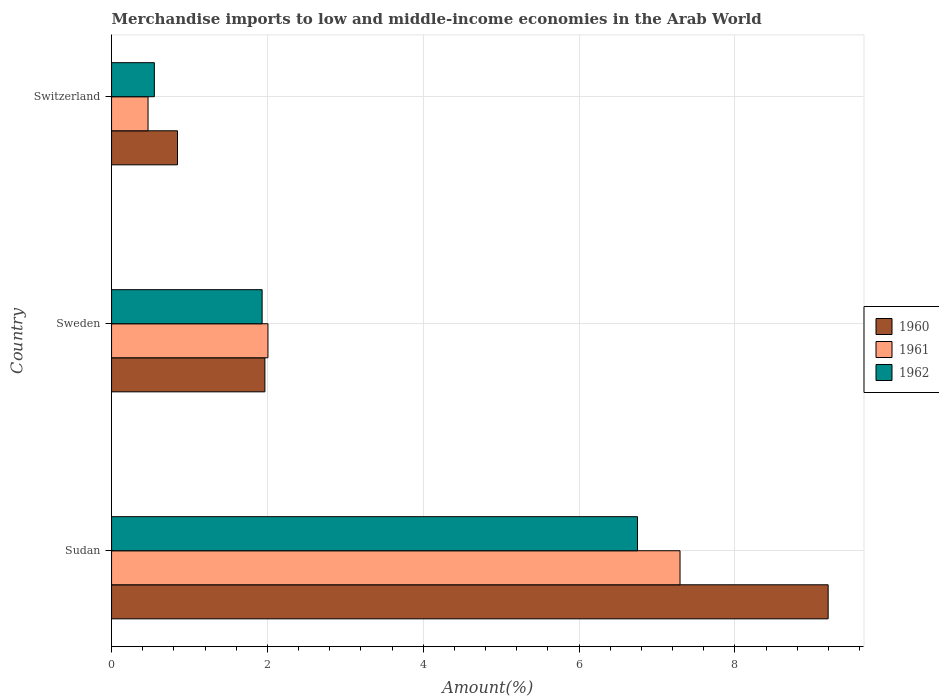How many groups of bars are there?
Keep it short and to the point. 3. Are the number of bars per tick equal to the number of legend labels?
Keep it short and to the point. Yes. Are the number of bars on each tick of the Y-axis equal?
Offer a terse response. Yes. How many bars are there on the 1st tick from the top?
Keep it short and to the point. 3. What is the label of the 2nd group of bars from the top?
Make the answer very short. Sweden. In how many cases, is the number of bars for a given country not equal to the number of legend labels?
Your response must be concise. 0. What is the percentage of amount earned from merchandise imports in 1960 in Sweden?
Provide a succinct answer. 1.97. Across all countries, what is the maximum percentage of amount earned from merchandise imports in 1961?
Give a very brief answer. 7.3. Across all countries, what is the minimum percentage of amount earned from merchandise imports in 1962?
Your answer should be very brief. 0.55. In which country was the percentage of amount earned from merchandise imports in 1962 maximum?
Make the answer very short. Sudan. In which country was the percentage of amount earned from merchandise imports in 1960 minimum?
Provide a succinct answer. Switzerland. What is the total percentage of amount earned from merchandise imports in 1962 in the graph?
Give a very brief answer. 9.23. What is the difference between the percentage of amount earned from merchandise imports in 1960 in Sudan and that in Sweden?
Offer a very short reply. 7.23. What is the difference between the percentage of amount earned from merchandise imports in 1960 in Switzerland and the percentage of amount earned from merchandise imports in 1961 in Sweden?
Give a very brief answer. -1.16. What is the average percentage of amount earned from merchandise imports in 1960 per country?
Keep it short and to the point. 4. What is the difference between the percentage of amount earned from merchandise imports in 1961 and percentage of amount earned from merchandise imports in 1960 in Sweden?
Keep it short and to the point. 0.04. What is the ratio of the percentage of amount earned from merchandise imports in 1962 in Sudan to that in Sweden?
Keep it short and to the point. 3.49. Is the percentage of amount earned from merchandise imports in 1961 in Sudan less than that in Sweden?
Give a very brief answer. No. Is the difference between the percentage of amount earned from merchandise imports in 1961 in Sweden and Switzerland greater than the difference between the percentage of amount earned from merchandise imports in 1960 in Sweden and Switzerland?
Keep it short and to the point. Yes. What is the difference between the highest and the second highest percentage of amount earned from merchandise imports in 1962?
Give a very brief answer. 4.82. What is the difference between the highest and the lowest percentage of amount earned from merchandise imports in 1962?
Provide a short and direct response. 6.2. Is the sum of the percentage of amount earned from merchandise imports in 1962 in Sweden and Switzerland greater than the maximum percentage of amount earned from merchandise imports in 1961 across all countries?
Your response must be concise. No. What does the 2nd bar from the bottom in Sweden represents?
Provide a succinct answer. 1961. How many bars are there?
Provide a short and direct response. 9. Are all the bars in the graph horizontal?
Your answer should be very brief. Yes. Does the graph contain any zero values?
Offer a very short reply. No. What is the title of the graph?
Your response must be concise. Merchandise imports to low and middle-income economies in the Arab World. Does "1966" appear as one of the legend labels in the graph?
Your response must be concise. No. What is the label or title of the X-axis?
Offer a terse response. Amount(%). What is the Amount(%) of 1960 in Sudan?
Your answer should be very brief. 9.2. What is the Amount(%) of 1961 in Sudan?
Your response must be concise. 7.3. What is the Amount(%) of 1962 in Sudan?
Provide a succinct answer. 6.75. What is the Amount(%) of 1960 in Sweden?
Make the answer very short. 1.97. What is the Amount(%) in 1961 in Sweden?
Your answer should be very brief. 2.01. What is the Amount(%) in 1962 in Sweden?
Your answer should be very brief. 1.93. What is the Amount(%) in 1960 in Switzerland?
Your answer should be compact. 0.85. What is the Amount(%) of 1961 in Switzerland?
Make the answer very short. 0.47. What is the Amount(%) of 1962 in Switzerland?
Give a very brief answer. 0.55. Across all countries, what is the maximum Amount(%) in 1960?
Keep it short and to the point. 9.2. Across all countries, what is the maximum Amount(%) of 1961?
Make the answer very short. 7.3. Across all countries, what is the maximum Amount(%) of 1962?
Provide a succinct answer. 6.75. Across all countries, what is the minimum Amount(%) of 1960?
Offer a very short reply. 0.85. Across all countries, what is the minimum Amount(%) in 1961?
Your response must be concise. 0.47. Across all countries, what is the minimum Amount(%) in 1962?
Your response must be concise. 0.55. What is the total Amount(%) of 1960 in the graph?
Your answer should be compact. 12.01. What is the total Amount(%) of 1961 in the graph?
Ensure brevity in your answer.  9.77. What is the total Amount(%) of 1962 in the graph?
Provide a succinct answer. 9.23. What is the difference between the Amount(%) of 1960 in Sudan and that in Sweden?
Offer a terse response. 7.23. What is the difference between the Amount(%) in 1961 in Sudan and that in Sweden?
Your answer should be compact. 5.29. What is the difference between the Amount(%) in 1962 in Sudan and that in Sweden?
Your answer should be very brief. 4.82. What is the difference between the Amount(%) of 1960 in Sudan and that in Switzerland?
Your answer should be compact. 8.35. What is the difference between the Amount(%) in 1961 in Sudan and that in Switzerland?
Offer a terse response. 6.83. What is the difference between the Amount(%) in 1962 in Sudan and that in Switzerland?
Your answer should be very brief. 6.2. What is the difference between the Amount(%) in 1960 in Sweden and that in Switzerland?
Offer a very short reply. 1.12. What is the difference between the Amount(%) of 1961 in Sweden and that in Switzerland?
Give a very brief answer. 1.54. What is the difference between the Amount(%) in 1962 in Sweden and that in Switzerland?
Offer a very short reply. 1.38. What is the difference between the Amount(%) of 1960 in Sudan and the Amount(%) of 1961 in Sweden?
Give a very brief answer. 7.19. What is the difference between the Amount(%) of 1960 in Sudan and the Amount(%) of 1962 in Sweden?
Your answer should be compact. 7.26. What is the difference between the Amount(%) in 1961 in Sudan and the Amount(%) in 1962 in Sweden?
Offer a terse response. 5.36. What is the difference between the Amount(%) in 1960 in Sudan and the Amount(%) in 1961 in Switzerland?
Your answer should be compact. 8.73. What is the difference between the Amount(%) of 1960 in Sudan and the Amount(%) of 1962 in Switzerland?
Your answer should be very brief. 8.65. What is the difference between the Amount(%) of 1961 in Sudan and the Amount(%) of 1962 in Switzerland?
Provide a short and direct response. 6.75. What is the difference between the Amount(%) of 1960 in Sweden and the Amount(%) of 1961 in Switzerland?
Your answer should be very brief. 1.5. What is the difference between the Amount(%) in 1960 in Sweden and the Amount(%) in 1962 in Switzerland?
Your answer should be very brief. 1.42. What is the difference between the Amount(%) of 1961 in Sweden and the Amount(%) of 1962 in Switzerland?
Your answer should be very brief. 1.46. What is the average Amount(%) in 1960 per country?
Your answer should be very brief. 4. What is the average Amount(%) of 1961 per country?
Your answer should be compact. 3.26. What is the average Amount(%) of 1962 per country?
Your answer should be compact. 3.08. What is the difference between the Amount(%) in 1960 and Amount(%) in 1961 in Sudan?
Ensure brevity in your answer.  1.9. What is the difference between the Amount(%) of 1960 and Amount(%) of 1962 in Sudan?
Keep it short and to the point. 2.45. What is the difference between the Amount(%) in 1961 and Amount(%) in 1962 in Sudan?
Offer a terse response. 0.55. What is the difference between the Amount(%) of 1960 and Amount(%) of 1961 in Sweden?
Provide a short and direct response. -0.04. What is the difference between the Amount(%) in 1960 and Amount(%) in 1962 in Sweden?
Your answer should be very brief. 0.04. What is the difference between the Amount(%) in 1961 and Amount(%) in 1962 in Sweden?
Your response must be concise. 0.07. What is the difference between the Amount(%) of 1960 and Amount(%) of 1961 in Switzerland?
Your response must be concise. 0.38. What is the difference between the Amount(%) in 1960 and Amount(%) in 1962 in Switzerland?
Offer a terse response. 0.3. What is the difference between the Amount(%) of 1961 and Amount(%) of 1962 in Switzerland?
Give a very brief answer. -0.08. What is the ratio of the Amount(%) in 1960 in Sudan to that in Sweden?
Make the answer very short. 4.67. What is the ratio of the Amount(%) of 1961 in Sudan to that in Sweden?
Give a very brief answer. 3.63. What is the ratio of the Amount(%) in 1962 in Sudan to that in Sweden?
Make the answer very short. 3.49. What is the ratio of the Amount(%) in 1960 in Sudan to that in Switzerland?
Offer a very short reply. 10.87. What is the ratio of the Amount(%) of 1961 in Sudan to that in Switzerland?
Give a very brief answer. 15.58. What is the ratio of the Amount(%) in 1962 in Sudan to that in Switzerland?
Provide a succinct answer. 12.29. What is the ratio of the Amount(%) in 1960 in Sweden to that in Switzerland?
Give a very brief answer. 2.33. What is the ratio of the Amount(%) of 1961 in Sweden to that in Switzerland?
Your response must be concise. 4.29. What is the ratio of the Amount(%) of 1962 in Sweden to that in Switzerland?
Make the answer very short. 3.52. What is the difference between the highest and the second highest Amount(%) in 1960?
Your answer should be compact. 7.23. What is the difference between the highest and the second highest Amount(%) in 1961?
Provide a succinct answer. 5.29. What is the difference between the highest and the second highest Amount(%) of 1962?
Ensure brevity in your answer.  4.82. What is the difference between the highest and the lowest Amount(%) in 1960?
Ensure brevity in your answer.  8.35. What is the difference between the highest and the lowest Amount(%) in 1961?
Provide a short and direct response. 6.83. What is the difference between the highest and the lowest Amount(%) of 1962?
Provide a short and direct response. 6.2. 